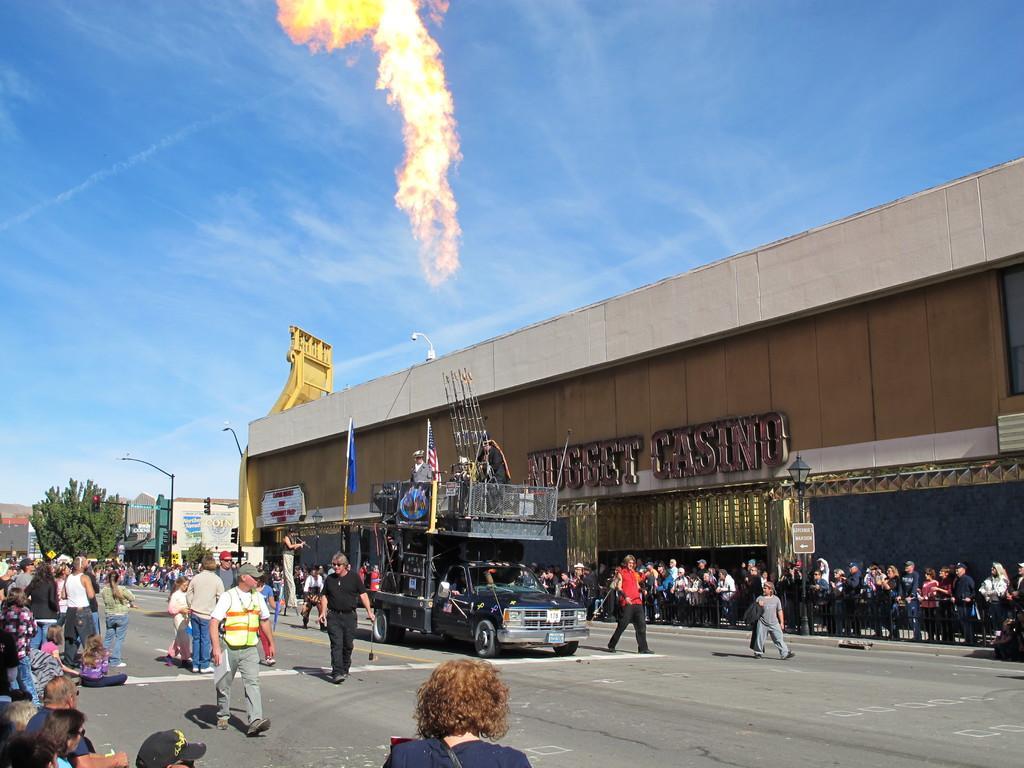Please provide a concise description of this image. In the image in the center, we can see one vehicle. And we can see a group of people are standing. In the background, we can see the sky, clouds, buildings, poles, sign boards, flags etc. 